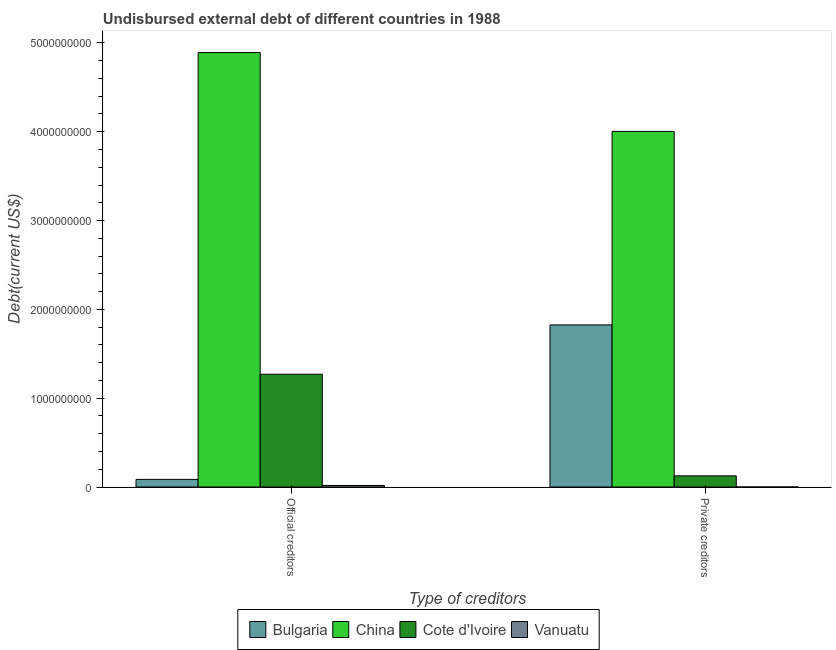Are the number of bars per tick equal to the number of legend labels?
Keep it short and to the point. Yes. How many bars are there on the 1st tick from the left?
Give a very brief answer. 4. What is the label of the 1st group of bars from the left?
Make the answer very short. Official creditors. What is the undisbursed external debt of official creditors in Cote d'Ivoire?
Make the answer very short. 1.27e+09. Across all countries, what is the maximum undisbursed external debt of official creditors?
Offer a very short reply. 4.89e+09. Across all countries, what is the minimum undisbursed external debt of official creditors?
Keep it short and to the point. 1.77e+07. In which country was the undisbursed external debt of private creditors minimum?
Your response must be concise. Vanuatu. What is the total undisbursed external debt of official creditors in the graph?
Keep it short and to the point. 6.27e+09. What is the difference between the undisbursed external debt of private creditors in China and that in Bulgaria?
Your response must be concise. 2.18e+09. What is the difference between the undisbursed external debt of private creditors in Cote d'Ivoire and the undisbursed external debt of official creditors in Vanuatu?
Offer a terse response. 1.08e+08. What is the average undisbursed external debt of official creditors per country?
Give a very brief answer. 1.57e+09. What is the difference between the undisbursed external debt of private creditors and undisbursed external debt of official creditors in Cote d'Ivoire?
Your response must be concise. -1.14e+09. What is the ratio of the undisbursed external debt of official creditors in Vanuatu to that in China?
Your answer should be compact. 0. In how many countries, is the undisbursed external debt of private creditors greater than the average undisbursed external debt of private creditors taken over all countries?
Provide a succinct answer. 2. What does the 3rd bar from the left in Private creditors represents?
Make the answer very short. Cote d'Ivoire. How many bars are there?
Provide a succinct answer. 8. Are the values on the major ticks of Y-axis written in scientific E-notation?
Offer a very short reply. No. How many legend labels are there?
Ensure brevity in your answer.  4. How are the legend labels stacked?
Keep it short and to the point. Horizontal. What is the title of the graph?
Offer a very short reply. Undisbursed external debt of different countries in 1988. Does "Australia" appear as one of the legend labels in the graph?
Ensure brevity in your answer.  No. What is the label or title of the X-axis?
Ensure brevity in your answer.  Type of creditors. What is the label or title of the Y-axis?
Offer a terse response. Debt(current US$). What is the Debt(current US$) in Bulgaria in Official creditors?
Make the answer very short. 8.59e+07. What is the Debt(current US$) of China in Official creditors?
Give a very brief answer. 4.89e+09. What is the Debt(current US$) in Cote d'Ivoire in Official creditors?
Offer a terse response. 1.27e+09. What is the Debt(current US$) in Vanuatu in Official creditors?
Make the answer very short. 1.77e+07. What is the Debt(current US$) of Bulgaria in Private creditors?
Offer a terse response. 1.83e+09. What is the Debt(current US$) in China in Private creditors?
Ensure brevity in your answer.  4.00e+09. What is the Debt(current US$) of Cote d'Ivoire in Private creditors?
Your answer should be compact. 1.26e+08. What is the Debt(current US$) of Vanuatu in Private creditors?
Offer a very short reply. 2.14e+05. Across all Type of creditors, what is the maximum Debt(current US$) of Bulgaria?
Your response must be concise. 1.83e+09. Across all Type of creditors, what is the maximum Debt(current US$) of China?
Your answer should be very brief. 4.89e+09. Across all Type of creditors, what is the maximum Debt(current US$) in Cote d'Ivoire?
Offer a very short reply. 1.27e+09. Across all Type of creditors, what is the maximum Debt(current US$) of Vanuatu?
Offer a terse response. 1.77e+07. Across all Type of creditors, what is the minimum Debt(current US$) of Bulgaria?
Your answer should be very brief. 8.59e+07. Across all Type of creditors, what is the minimum Debt(current US$) of China?
Provide a succinct answer. 4.00e+09. Across all Type of creditors, what is the minimum Debt(current US$) of Cote d'Ivoire?
Provide a succinct answer. 1.26e+08. Across all Type of creditors, what is the minimum Debt(current US$) in Vanuatu?
Offer a terse response. 2.14e+05. What is the total Debt(current US$) in Bulgaria in the graph?
Your answer should be very brief. 1.91e+09. What is the total Debt(current US$) in China in the graph?
Give a very brief answer. 8.90e+09. What is the total Debt(current US$) of Cote d'Ivoire in the graph?
Your response must be concise. 1.40e+09. What is the total Debt(current US$) in Vanuatu in the graph?
Give a very brief answer. 1.79e+07. What is the difference between the Debt(current US$) in Bulgaria in Official creditors and that in Private creditors?
Offer a terse response. -1.74e+09. What is the difference between the Debt(current US$) of China in Official creditors and that in Private creditors?
Give a very brief answer. 8.88e+08. What is the difference between the Debt(current US$) of Cote d'Ivoire in Official creditors and that in Private creditors?
Provide a succinct answer. 1.14e+09. What is the difference between the Debt(current US$) in Vanuatu in Official creditors and that in Private creditors?
Ensure brevity in your answer.  1.75e+07. What is the difference between the Debt(current US$) in Bulgaria in Official creditors and the Debt(current US$) in China in Private creditors?
Offer a terse response. -3.92e+09. What is the difference between the Debt(current US$) in Bulgaria in Official creditors and the Debt(current US$) in Cote d'Ivoire in Private creditors?
Your answer should be very brief. -3.97e+07. What is the difference between the Debt(current US$) in Bulgaria in Official creditors and the Debt(current US$) in Vanuatu in Private creditors?
Your response must be concise. 8.57e+07. What is the difference between the Debt(current US$) of China in Official creditors and the Debt(current US$) of Cote d'Ivoire in Private creditors?
Make the answer very short. 4.77e+09. What is the difference between the Debt(current US$) of China in Official creditors and the Debt(current US$) of Vanuatu in Private creditors?
Offer a very short reply. 4.89e+09. What is the difference between the Debt(current US$) of Cote d'Ivoire in Official creditors and the Debt(current US$) of Vanuatu in Private creditors?
Ensure brevity in your answer.  1.27e+09. What is the average Debt(current US$) of Bulgaria per Type of creditors?
Your answer should be compact. 9.56e+08. What is the average Debt(current US$) of China per Type of creditors?
Ensure brevity in your answer.  4.45e+09. What is the average Debt(current US$) in Cote d'Ivoire per Type of creditors?
Offer a very short reply. 6.98e+08. What is the average Debt(current US$) of Vanuatu per Type of creditors?
Provide a short and direct response. 8.94e+06. What is the difference between the Debt(current US$) of Bulgaria and Debt(current US$) of China in Official creditors?
Make the answer very short. -4.81e+09. What is the difference between the Debt(current US$) in Bulgaria and Debt(current US$) in Cote d'Ivoire in Official creditors?
Keep it short and to the point. -1.18e+09. What is the difference between the Debt(current US$) of Bulgaria and Debt(current US$) of Vanuatu in Official creditors?
Give a very brief answer. 6.83e+07. What is the difference between the Debt(current US$) of China and Debt(current US$) of Cote d'Ivoire in Official creditors?
Ensure brevity in your answer.  3.62e+09. What is the difference between the Debt(current US$) in China and Debt(current US$) in Vanuatu in Official creditors?
Ensure brevity in your answer.  4.87e+09. What is the difference between the Debt(current US$) of Cote d'Ivoire and Debt(current US$) of Vanuatu in Official creditors?
Your answer should be compact. 1.25e+09. What is the difference between the Debt(current US$) of Bulgaria and Debt(current US$) of China in Private creditors?
Offer a terse response. -2.18e+09. What is the difference between the Debt(current US$) of Bulgaria and Debt(current US$) of Cote d'Ivoire in Private creditors?
Provide a short and direct response. 1.70e+09. What is the difference between the Debt(current US$) of Bulgaria and Debt(current US$) of Vanuatu in Private creditors?
Your answer should be very brief. 1.82e+09. What is the difference between the Debt(current US$) in China and Debt(current US$) in Cote d'Ivoire in Private creditors?
Provide a succinct answer. 3.88e+09. What is the difference between the Debt(current US$) of China and Debt(current US$) of Vanuatu in Private creditors?
Make the answer very short. 4.00e+09. What is the difference between the Debt(current US$) in Cote d'Ivoire and Debt(current US$) in Vanuatu in Private creditors?
Your response must be concise. 1.25e+08. What is the ratio of the Debt(current US$) in Bulgaria in Official creditors to that in Private creditors?
Provide a short and direct response. 0.05. What is the ratio of the Debt(current US$) of China in Official creditors to that in Private creditors?
Give a very brief answer. 1.22. What is the ratio of the Debt(current US$) in Cote d'Ivoire in Official creditors to that in Private creditors?
Offer a terse response. 10.11. What is the ratio of the Debt(current US$) of Vanuatu in Official creditors to that in Private creditors?
Your answer should be very brief. 82.57. What is the difference between the highest and the second highest Debt(current US$) of Bulgaria?
Offer a terse response. 1.74e+09. What is the difference between the highest and the second highest Debt(current US$) in China?
Your answer should be very brief. 8.88e+08. What is the difference between the highest and the second highest Debt(current US$) in Cote d'Ivoire?
Make the answer very short. 1.14e+09. What is the difference between the highest and the second highest Debt(current US$) of Vanuatu?
Give a very brief answer. 1.75e+07. What is the difference between the highest and the lowest Debt(current US$) of Bulgaria?
Provide a short and direct response. 1.74e+09. What is the difference between the highest and the lowest Debt(current US$) in China?
Give a very brief answer. 8.88e+08. What is the difference between the highest and the lowest Debt(current US$) in Cote d'Ivoire?
Your response must be concise. 1.14e+09. What is the difference between the highest and the lowest Debt(current US$) in Vanuatu?
Provide a succinct answer. 1.75e+07. 